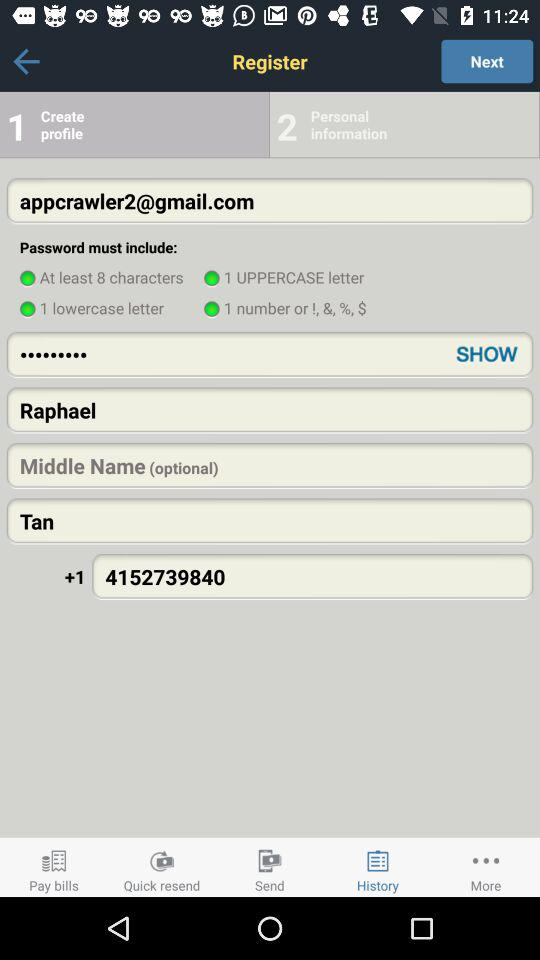How many numbers are in the phone number?
Answer the question using a single word or phrase. 10 